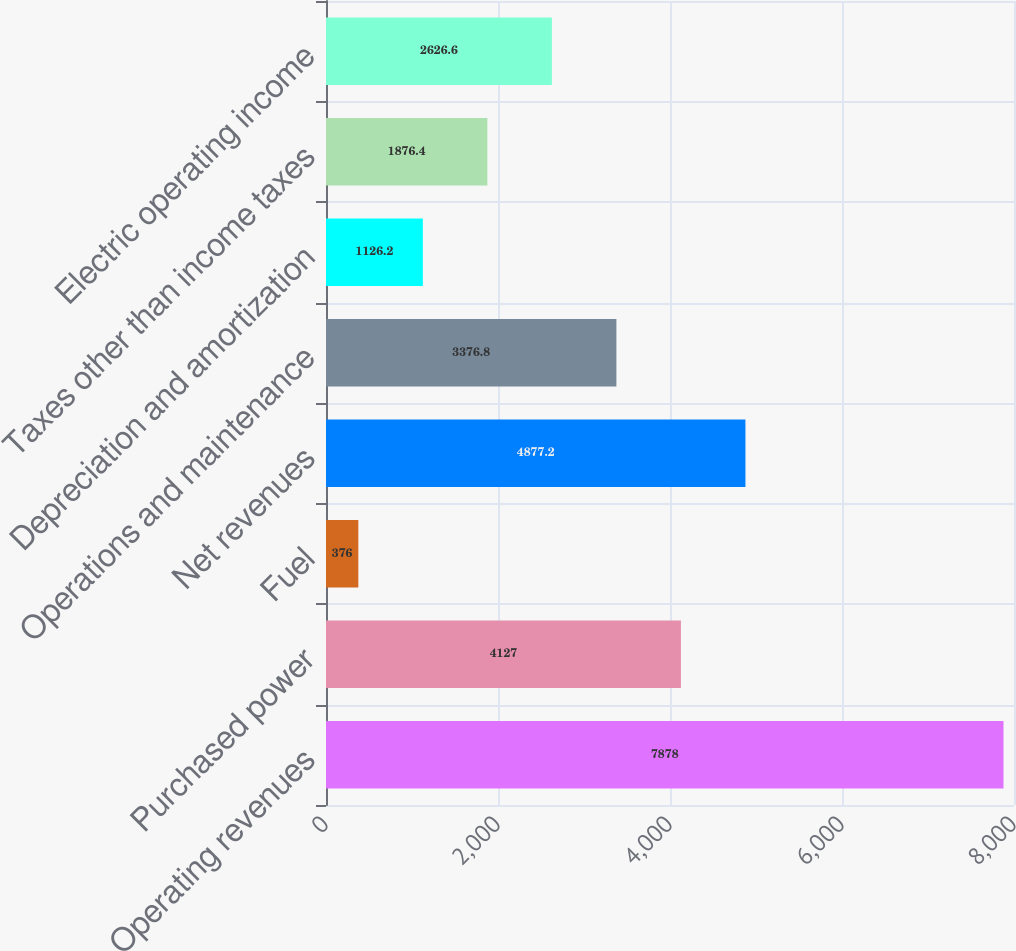Convert chart. <chart><loc_0><loc_0><loc_500><loc_500><bar_chart><fcel>Operating revenues<fcel>Purchased power<fcel>Fuel<fcel>Net revenues<fcel>Operations and maintenance<fcel>Depreciation and amortization<fcel>Taxes other than income taxes<fcel>Electric operating income<nl><fcel>7878<fcel>4127<fcel>376<fcel>4877.2<fcel>3376.8<fcel>1126.2<fcel>1876.4<fcel>2626.6<nl></chart> 